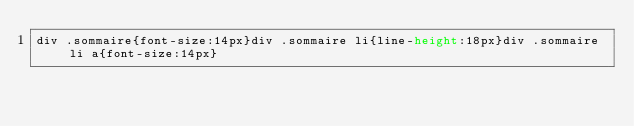<code> <loc_0><loc_0><loc_500><loc_500><_CSS_>div .sommaire{font-size:14px}div .sommaire li{line-height:18px}div .sommaire li a{font-size:14px}


</code> 